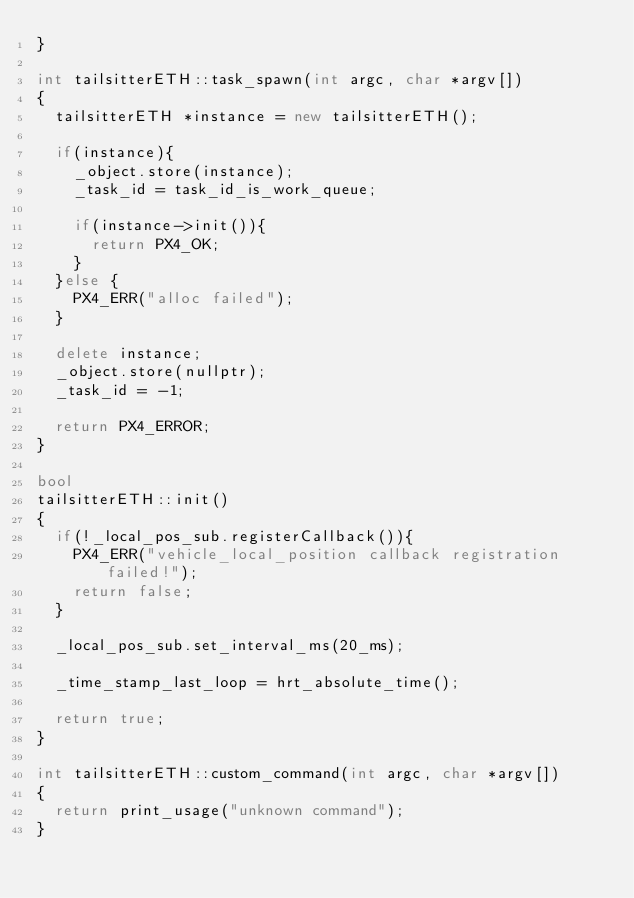<code> <loc_0><loc_0><loc_500><loc_500><_C++_>}

int tailsitterETH::task_spawn(int argc, char *argv[])
{
	tailsitterETH *instance = new tailsitterETH();

	if(instance){
		_object.store(instance);
		_task_id = task_id_is_work_queue;

		if(instance->init()){
			return PX4_OK;
		}
	}else {
		PX4_ERR("alloc failed");
	}

	delete instance;
	_object.store(nullptr);
	_task_id = -1;

	return PX4_ERROR;
}

bool
tailsitterETH::init()
{
	if(!_local_pos_sub.registerCallback()){
		PX4_ERR("vehicle_local_position callback registration failed!");
		return false;
	}

	_local_pos_sub.set_interval_ms(20_ms);

	_time_stamp_last_loop = hrt_absolute_time();

	return true;
}

int tailsitterETH::custom_command(int argc, char *argv[])
{
	return print_usage("unknown command");
}
</code> 